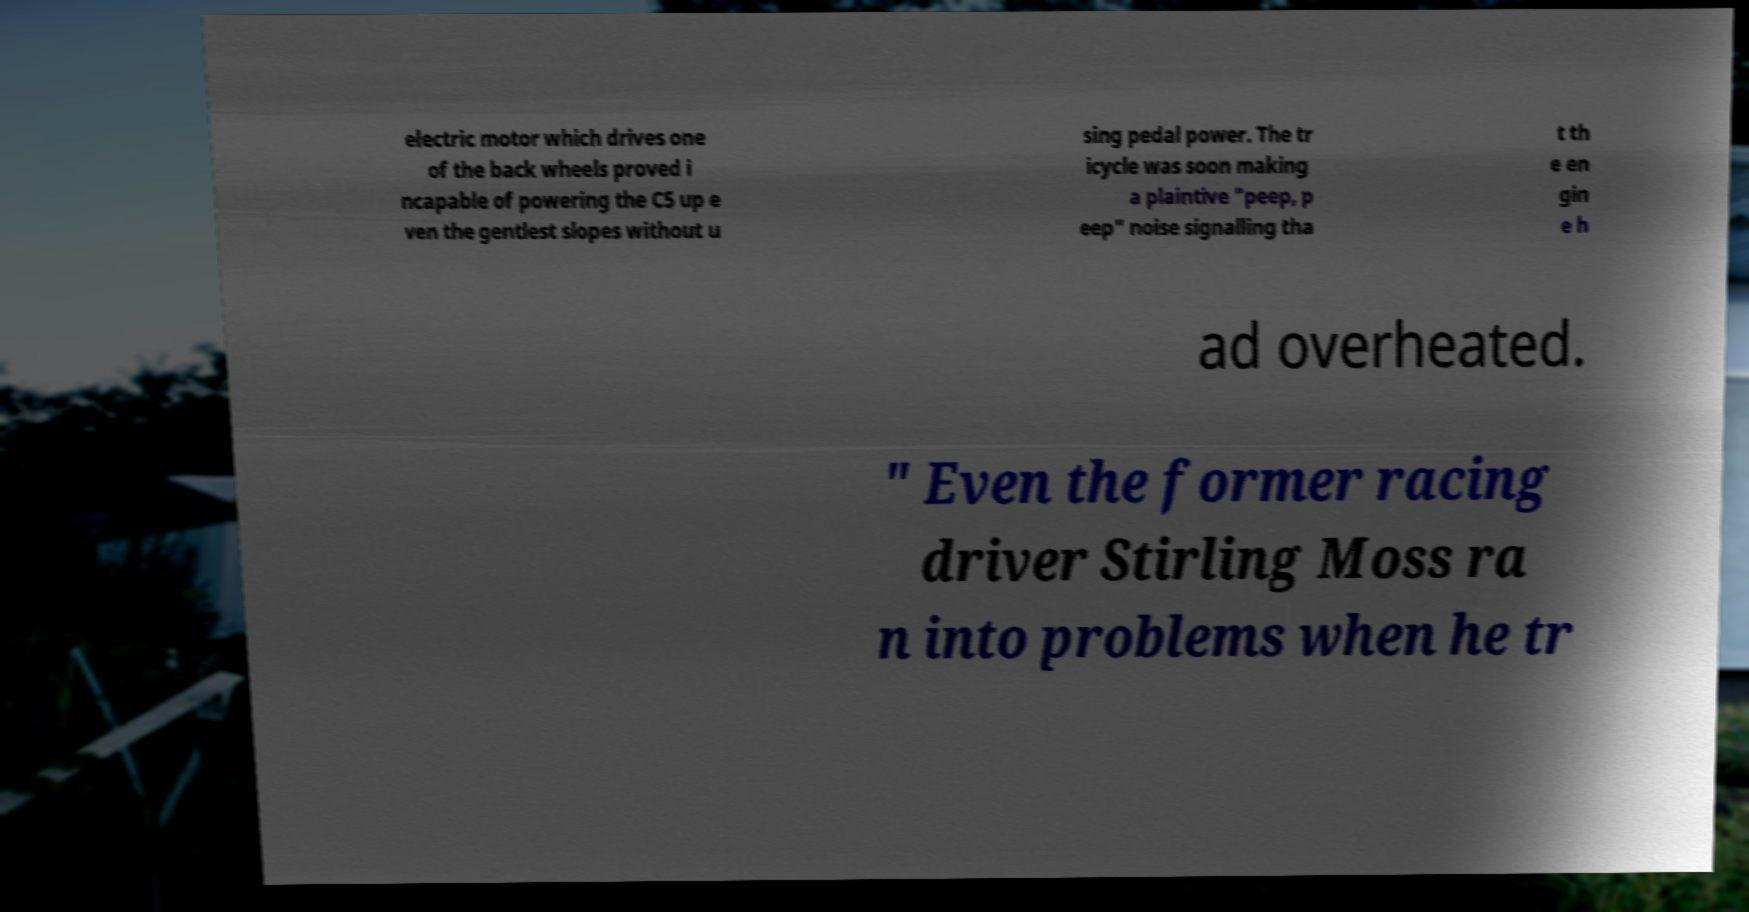Could you extract and type out the text from this image? electric motor which drives one of the back wheels proved i ncapable of powering the C5 up e ven the gentlest slopes without u sing pedal power. The tr icycle was soon making a plaintive "peep, p eep" noise signalling tha t th e en gin e h ad overheated. " Even the former racing driver Stirling Moss ra n into problems when he tr 